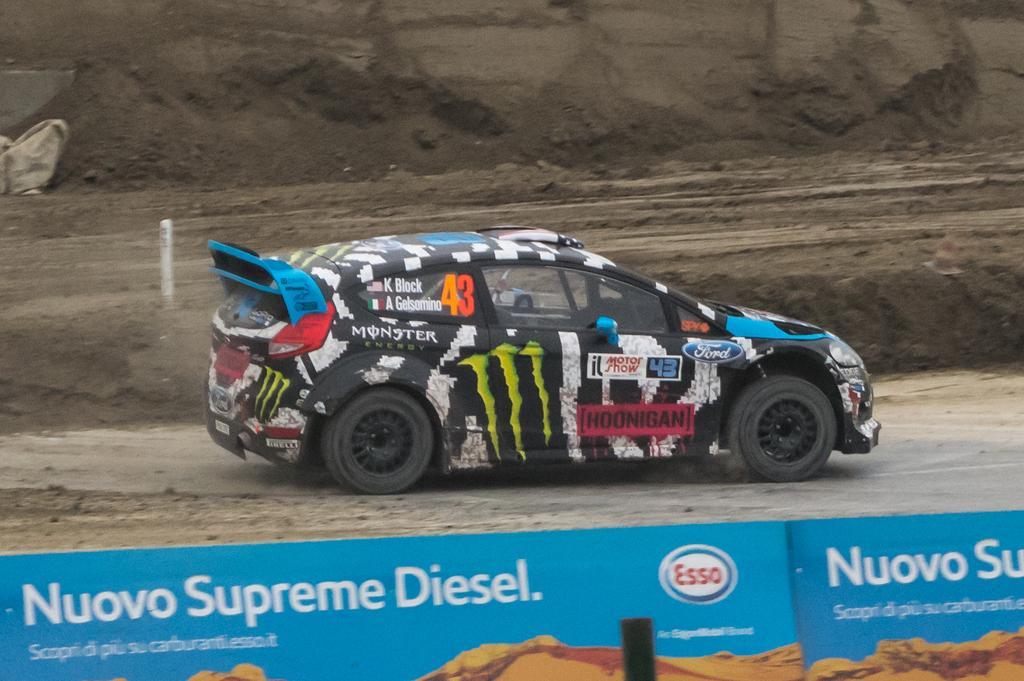How would you summarize this image in a sentence or two? In this image, we can see a vehicle on the road and in the background, we can see rocks and a pole. At the bottom, there is some text and a logo on the board. 